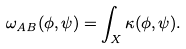Convert formula to latex. <formula><loc_0><loc_0><loc_500><loc_500>\omega _ { A B } ( \phi , \psi ) = \int _ { X } \kappa ( \phi , \psi ) .</formula> 